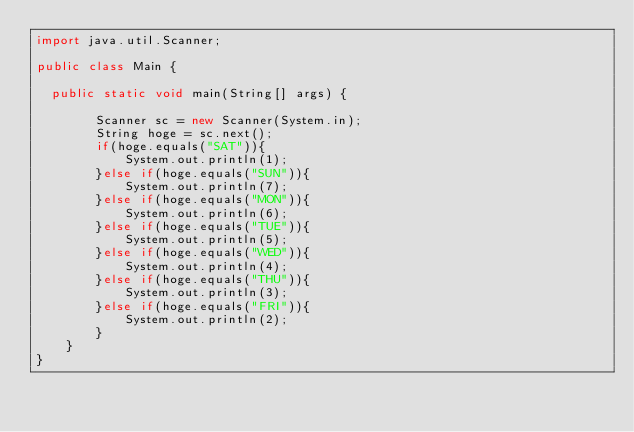Convert code to text. <code><loc_0><loc_0><loc_500><loc_500><_Java_>import java.util.Scanner;

public class Main {

	public static void main(String[] args) {
       
        Scanner sc = new Scanner(System.in);
        String hoge = sc.next();
        if(hoge.equals("SAT")){
            System.out.println(1);
        }else if(hoge.equals("SUN")){
            System.out.println(7);
        }else if(hoge.equals("MON")){
            System.out.println(6);
        }else if(hoge.equals("TUE")){
            System.out.println(5);
        }else if(hoge.equals("WED")){
            System.out.println(4);
        }else if(hoge.equals("THU")){
            System.out.println(3);
        }else if(hoge.equals("FRI")){
            System.out.println(2);
        }
    }     
}</code> 